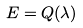Convert formula to latex. <formula><loc_0><loc_0><loc_500><loc_500>E = Q ( \lambda )</formula> 